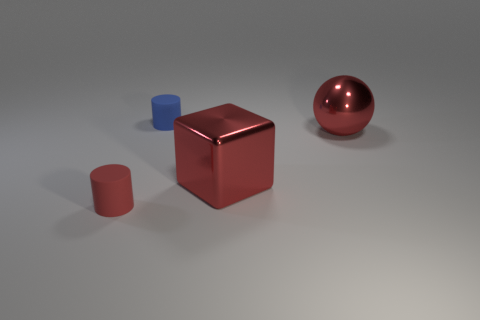Add 3 small cyan spheres. How many objects exist? 7 Subtract all blue cylinders. How many cylinders are left? 1 Subtract 0 brown blocks. How many objects are left? 4 Subtract all spheres. How many objects are left? 3 Subtract 1 cylinders. How many cylinders are left? 1 Subtract all green cylinders. Subtract all yellow spheres. How many cylinders are left? 2 Subtract all big cyan cylinders. Subtract all red metal objects. How many objects are left? 2 Add 3 red cubes. How many red cubes are left? 4 Add 2 shiny objects. How many shiny objects exist? 4 